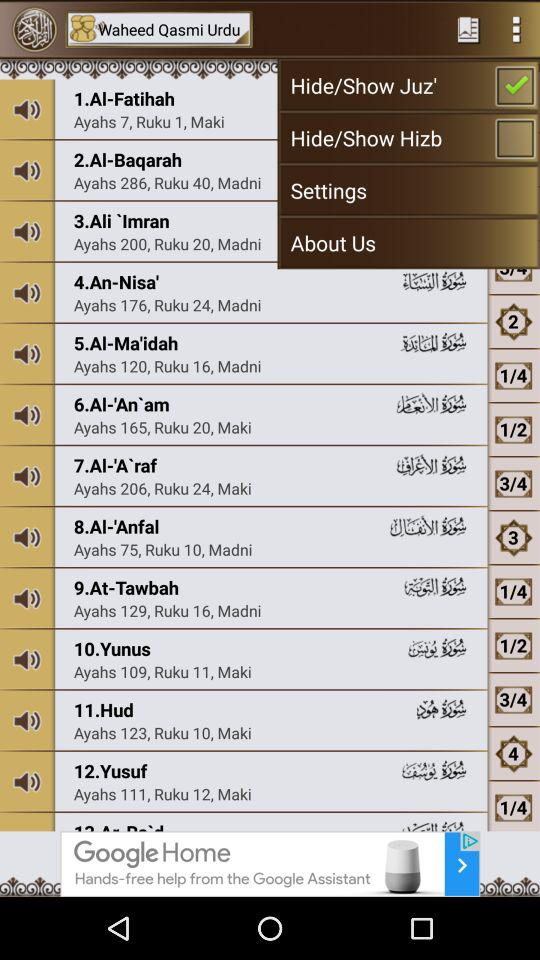How many ayahs are there in "Yunus"? There are 109 ayahs in "Yunus". 